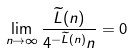<formula> <loc_0><loc_0><loc_500><loc_500>\lim _ { n \to \infty } \frac { \widetilde { L } ( n ) } { 4 ^ { - \widetilde { L } ( n ) } n } = 0</formula> 